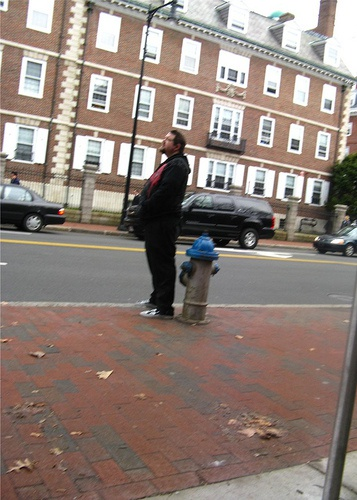Describe the objects in this image and their specific colors. I can see people in ivory, black, gray, and maroon tones, car in ivory, black, darkgray, and gray tones, fire hydrant in ivory, gray, and black tones, car in ivory, black, darkgray, gray, and lightgray tones, and car in ivory, black, gray, darkgray, and white tones in this image. 